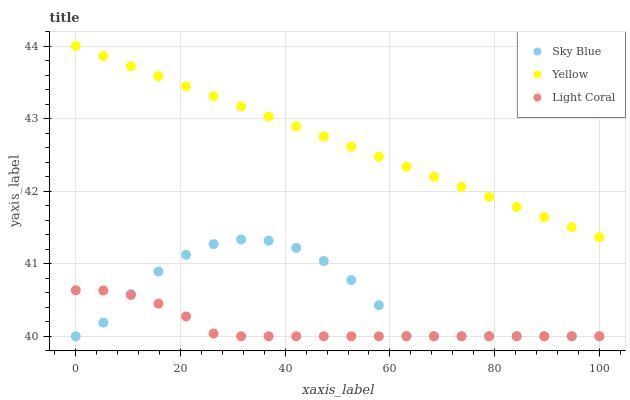Does Light Coral have the minimum area under the curve?
Answer yes or no. Yes. Does Yellow have the maximum area under the curve?
Answer yes or no. Yes. Does Sky Blue have the minimum area under the curve?
Answer yes or no. No. Does Sky Blue have the maximum area under the curve?
Answer yes or no. No. Is Yellow the smoothest?
Answer yes or no. Yes. Is Sky Blue the roughest?
Answer yes or no. Yes. Is Sky Blue the smoothest?
Answer yes or no. No. Is Yellow the roughest?
Answer yes or no. No. Does Light Coral have the lowest value?
Answer yes or no. Yes. Does Yellow have the lowest value?
Answer yes or no. No. Does Yellow have the highest value?
Answer yes or no. Yes. Does Sky Blue have the highest value?
Answer yes or no. No. Is Light Coral less than Yellow?
Answer yes or no. Yes. Is Yellow greater than Sky Blue?
Answer yes or no. Yes. Does Light Coral intersect Sky Blue?
Answer yes or no. Yes. Is Light Coral less than Sky Blue?
Answer yes or no. No. Is Light Coral greater than Sky Blue?
Answer yes or no. No. Does Light Coral intersect Yellow?
Answer yes or no. No. 